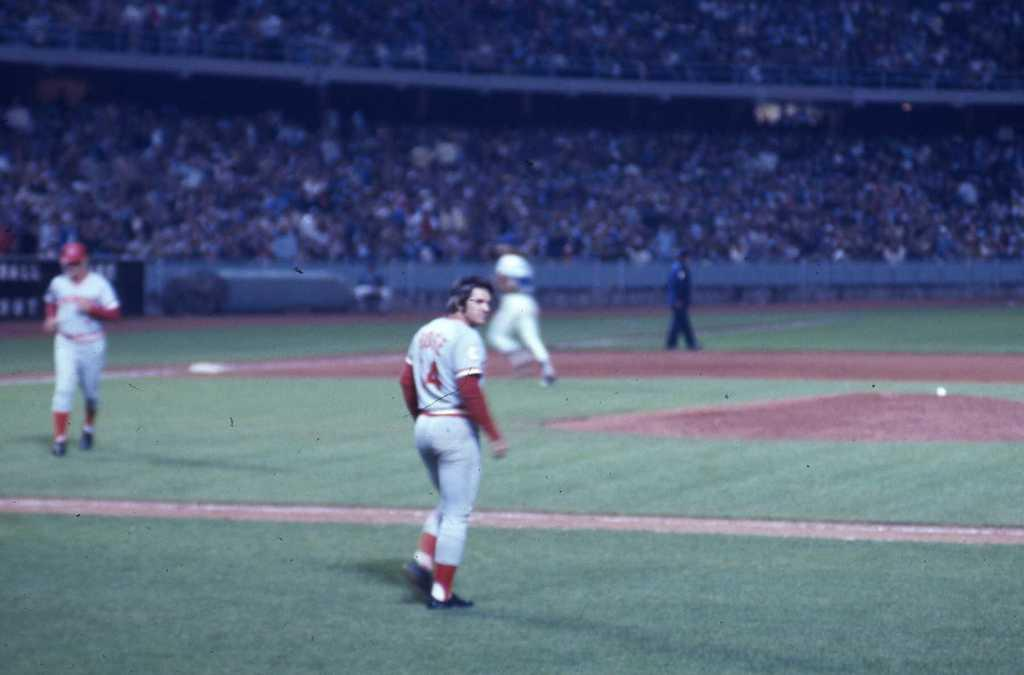Provide a one-sentence caption for the provided image. A baseball player wearing number 4 walks out to the field. 